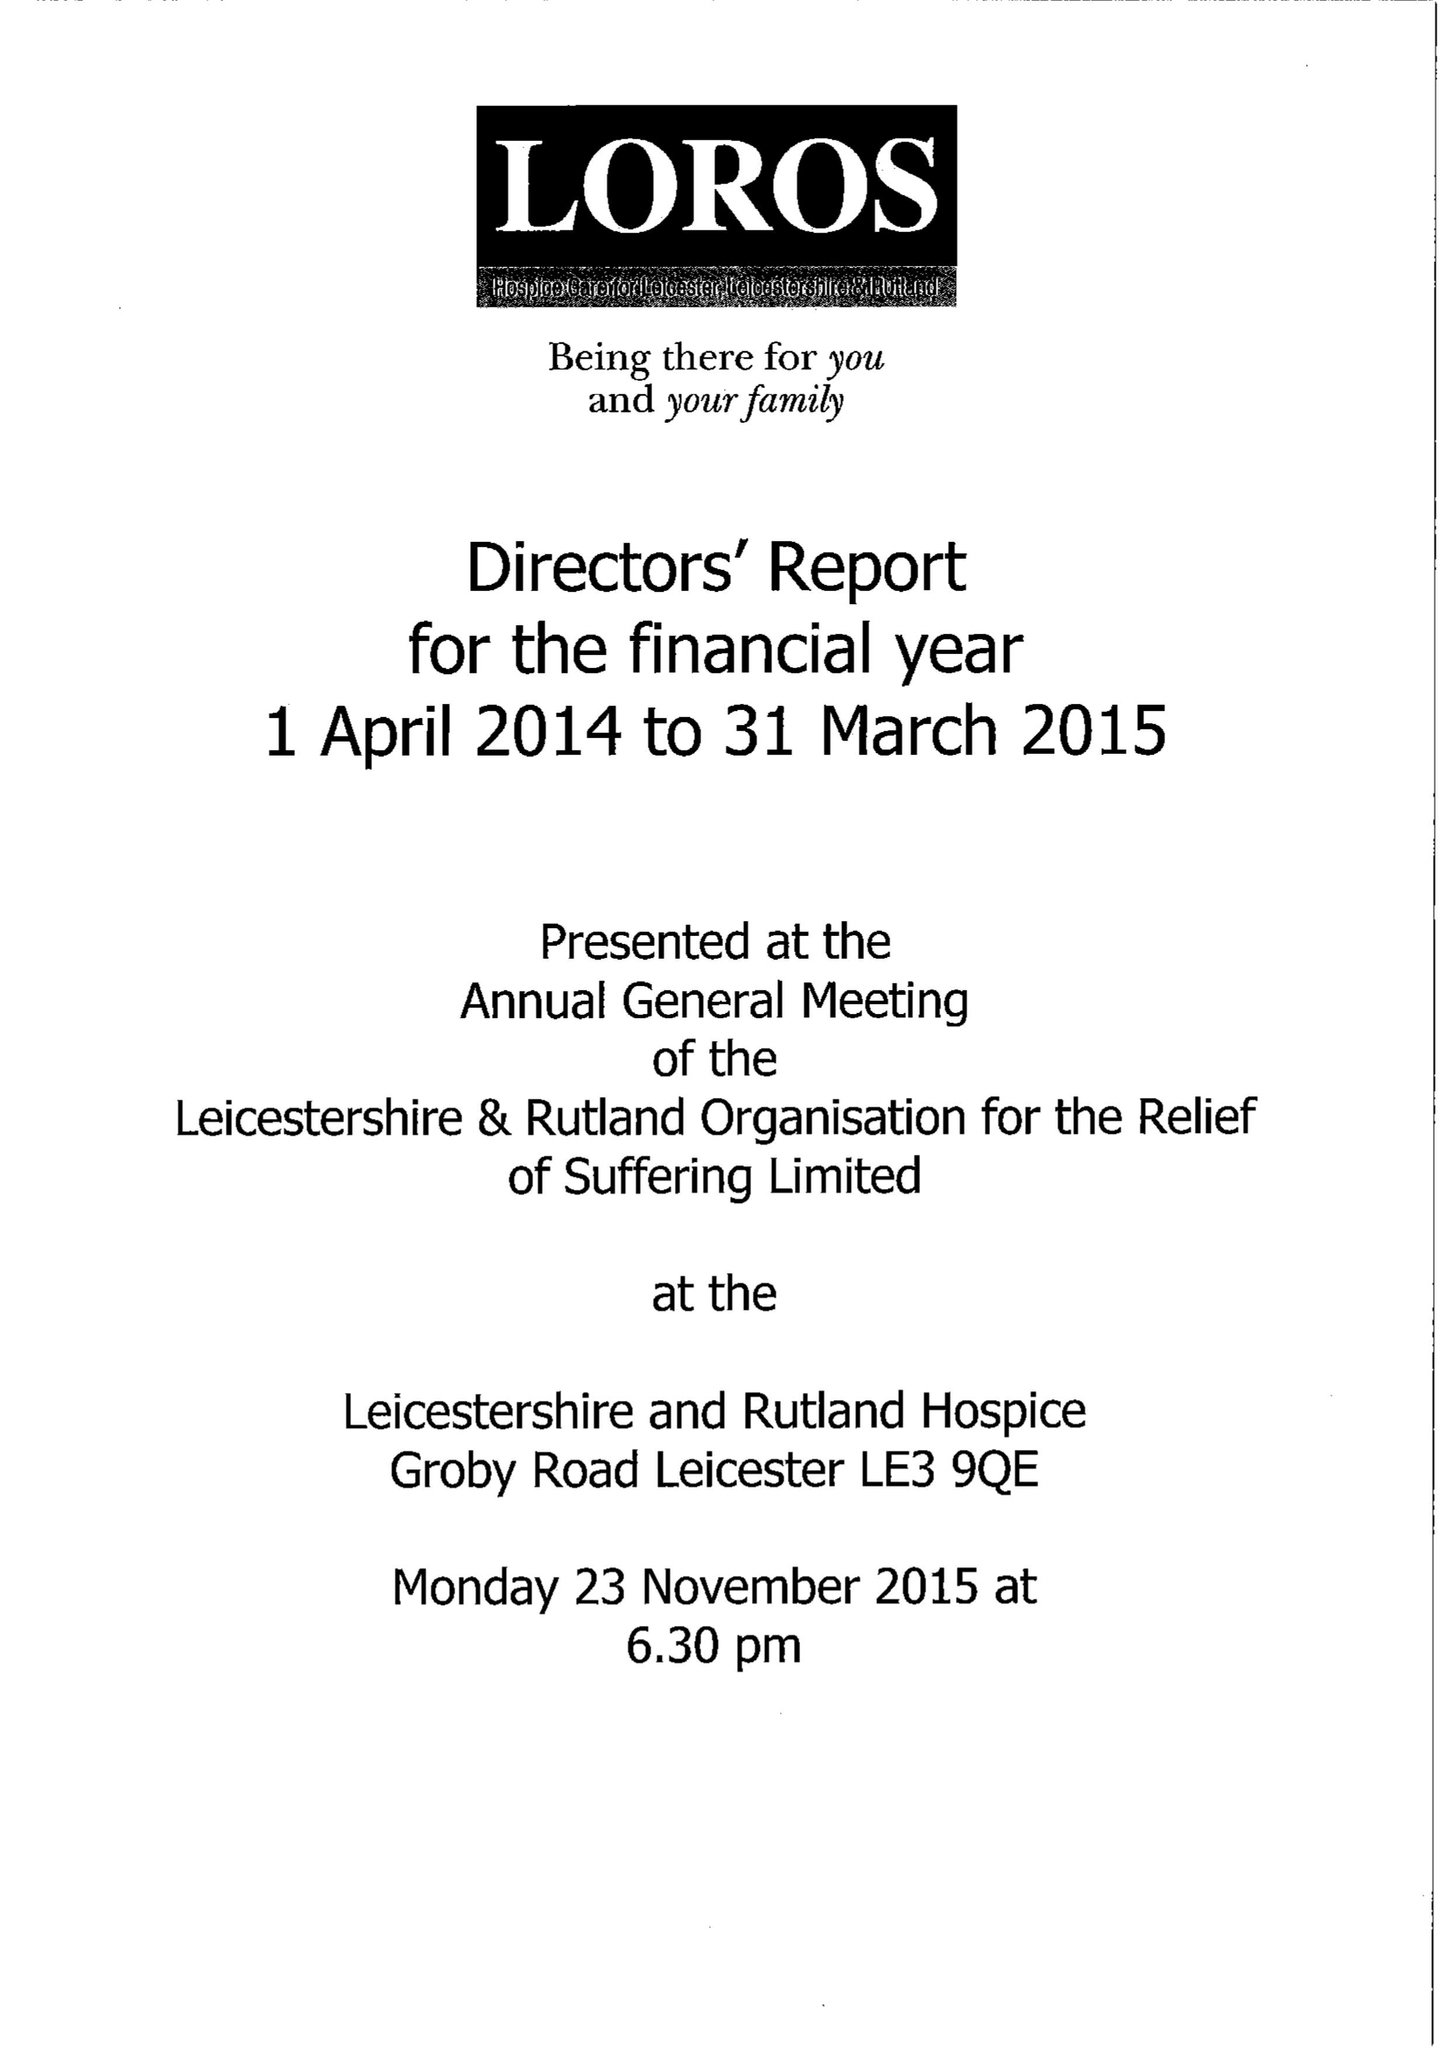What is the value for the charity_number?
Answer the question using a single word or phrase. 506120 